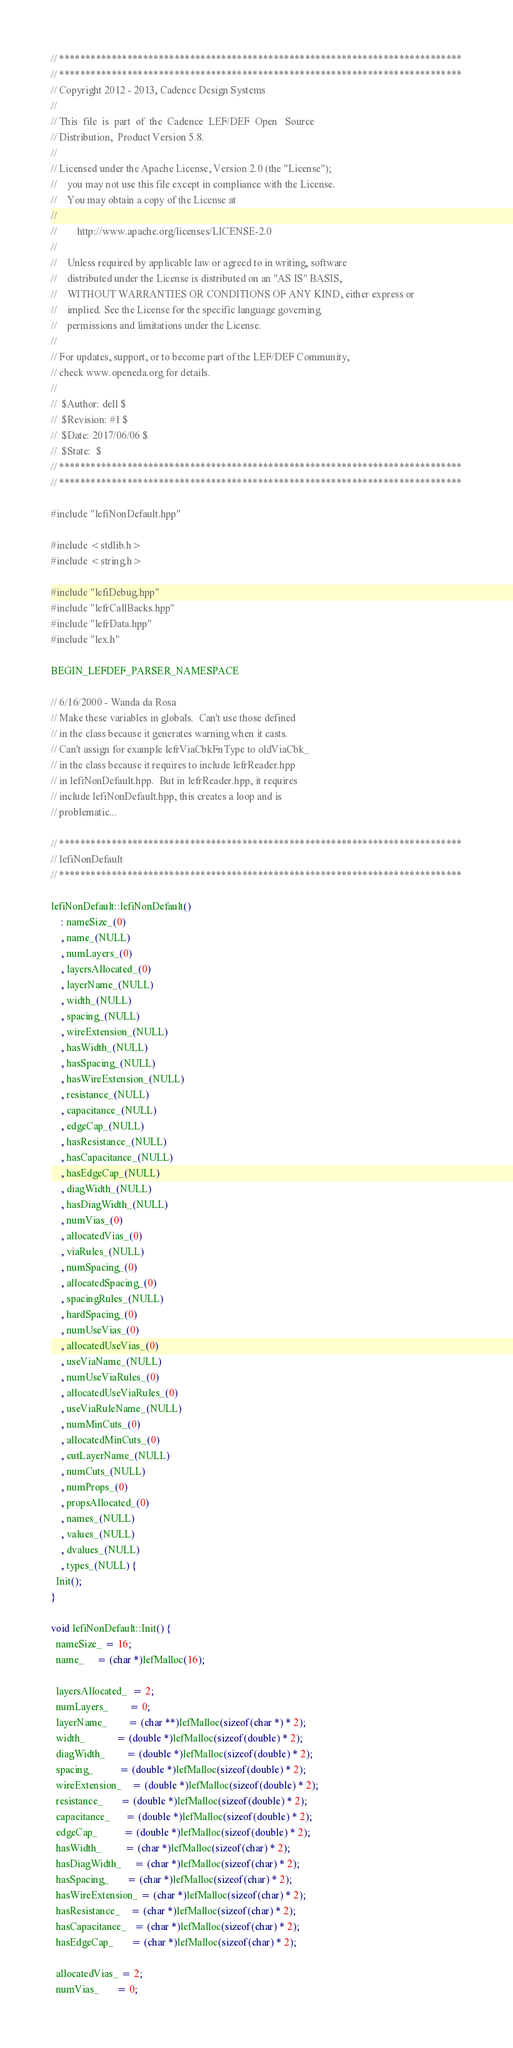<code> <loc_0><loc_0><loc_500><loc_500><_C++_>// *****************************************************************************
// *****************************************************************************
// Copyright 2012 - 2013, Cadence Design Systems
//
// This  file  is  part  of  the  Cadence  LEF/DEF  Open   Source
// Distribution,  Product Version 5.8.
//
// Licensed under the Apache License, Version 2.0 (the "License");
//    you may not use this file except in compliance with the License.
//    You may obtain a copy of the License at
//
//        http://www.apache.org/licenses/LICENSE-2.0
//
//    Unless required by applicable law or agreed to in writing, software
//    distributed under the License is distributed on an "AS IS" BASIS,
//    WITHOUT WARRANTIES OR CONDITIONS OF ANY KIND, either express or
//    implied. See the License for the specific language governing
//    permissions and limitations under the License.
//
// For updates, support, or to become part of the LEF/DEF Community,
// check www.openeda.org for details.
//
//  $Author: dell $
//  $Revision: #1 $
//  $Date: 2017/06/06 $
//  $State:  $
// *****************************************************************************
// *****************************************************************************

#include "lefiNonDefault.hpp"

#include <stdlib.h>
#include <string.h>

#include "lefiDebug.hpp"
#include "lefrCallBacks.hpp"
#include "lefrData.hpp"
#include "lex.h"

BEGIN_LEFDEF_PARSER_NAMESPACE

// 6/16/2000 - Wanda da Rosa
// Make these variables in globals.  Can't use those defined
// in the class because it generates warning when it casts.
// Can't assign for example lefrViaCbkFnType to oldViaCbk_
// in the class because it requires to include lefrReader.hpp
// in lefiNonDefault.hpp.  But in lefrReader.hpp, it requires
// include lefiNonDefault.hpp, this creates a loop and is
// problematic...

// *****************************************************************************
// lefiNonDefault
// *****************************************************************************

lefiNonDefault::lefiNonDefault()
    : nameSize_(0)
    , name_(NULL)
    , numLayers_(0)
    , layersAllocated_(0)
    , layerName_(NULL)
    , width_(NULL)
    , spacing_(NULL)
    , wireExtension_(NULL)
    , hasWidth_(NULL)
    , hasSpacing_(NULL)
    , hasWireExtension_(NULL)
    , resistance_(NULL)
    , capacitance_(NULL)
    , edgeCap_(NULL)
    , hasResistance_(NULL)
    , hasCapacitance_(NULL)
    , hasEdgeCap_(NULL)
    , diagWidth_(NULL)
    , hasDiagWidth_(NULL)
    , numVias_(0)
    , allocatedVias_(0)
    , viaRules_(NULL)
    , numSpacing_(0)
    , allocatedSpacing_(0)
    , spacingRules_(NULL)
    , hardSpacing_(0)
    , numUseVias_(0)
    , allocatedUseVias_(0)
    , useViaName_(NULL)
    , numUseViaRules_(0)
    , allocatedUseViaRules_(0)
    , useViaRuleName_(NULL)
    , numMinCuts_(0)
    , allocatedMinCuts_(0)
    , cutLayerName_(NULL)
    , numCuts_(NULL)
    , numProps_(0)
    , propsAllocated_(0)
    , names_(NULL)
    , values_(NULL)
    , dvalues_(NULL)
    , types_(NULL) {
  Init();
}

void lefiNonDefault::Init() {
  nameSize_ = 16;
  name_     = (char *)lefMalloc(16);

  layersAllocated_  = 2;
  numLayers_        = 0;
  layerName_        = (char **)lefMalloc(sizeof(char *) * 2);
  width_            = (double *)lefMalloc(sizeof(double) * 2);
  diagWidth_        = (double *)lefMalloc(sizeof(double) * 2);
  spacing_          = (double *)lefMalloc(sizeof(double) * 2);
  wireExtension_    = (double *)lefMalloc(sizeof(double) * 2);
  resistance_       = (double *)lefMalloc(sizeof(double) * 2);
  capacitance_      = (double *)lefMalloc(sizeof(double) * 2);
  edgeCap_          = (double *)lefMalloc(sizeof(double) * 2);
  hasWidth_         = (char *)lefMalloc(sizeof(char) * 2);
  hasDiagWidth_     = (char *)lefMalloc(sizeof(char) * 2);
  hasSpacing_       = (char *)lefMalloc(sizeof(char) * 2);
  hasWireExtension_ = (char *)lefMalloc(sizeof(char) * 2);
  hasResistance_    = (char *)lefMalloc(sizeof(char) * 2);
  hasCapacitance_   = (char *)lefMalloc(sizeof(char) * 2);
  hasEdgeCap_       = (char *)lefMalloc(sizeof(char) * 2);

  allocatedVias_ = 2;
  numVias_       = 0;</code> 